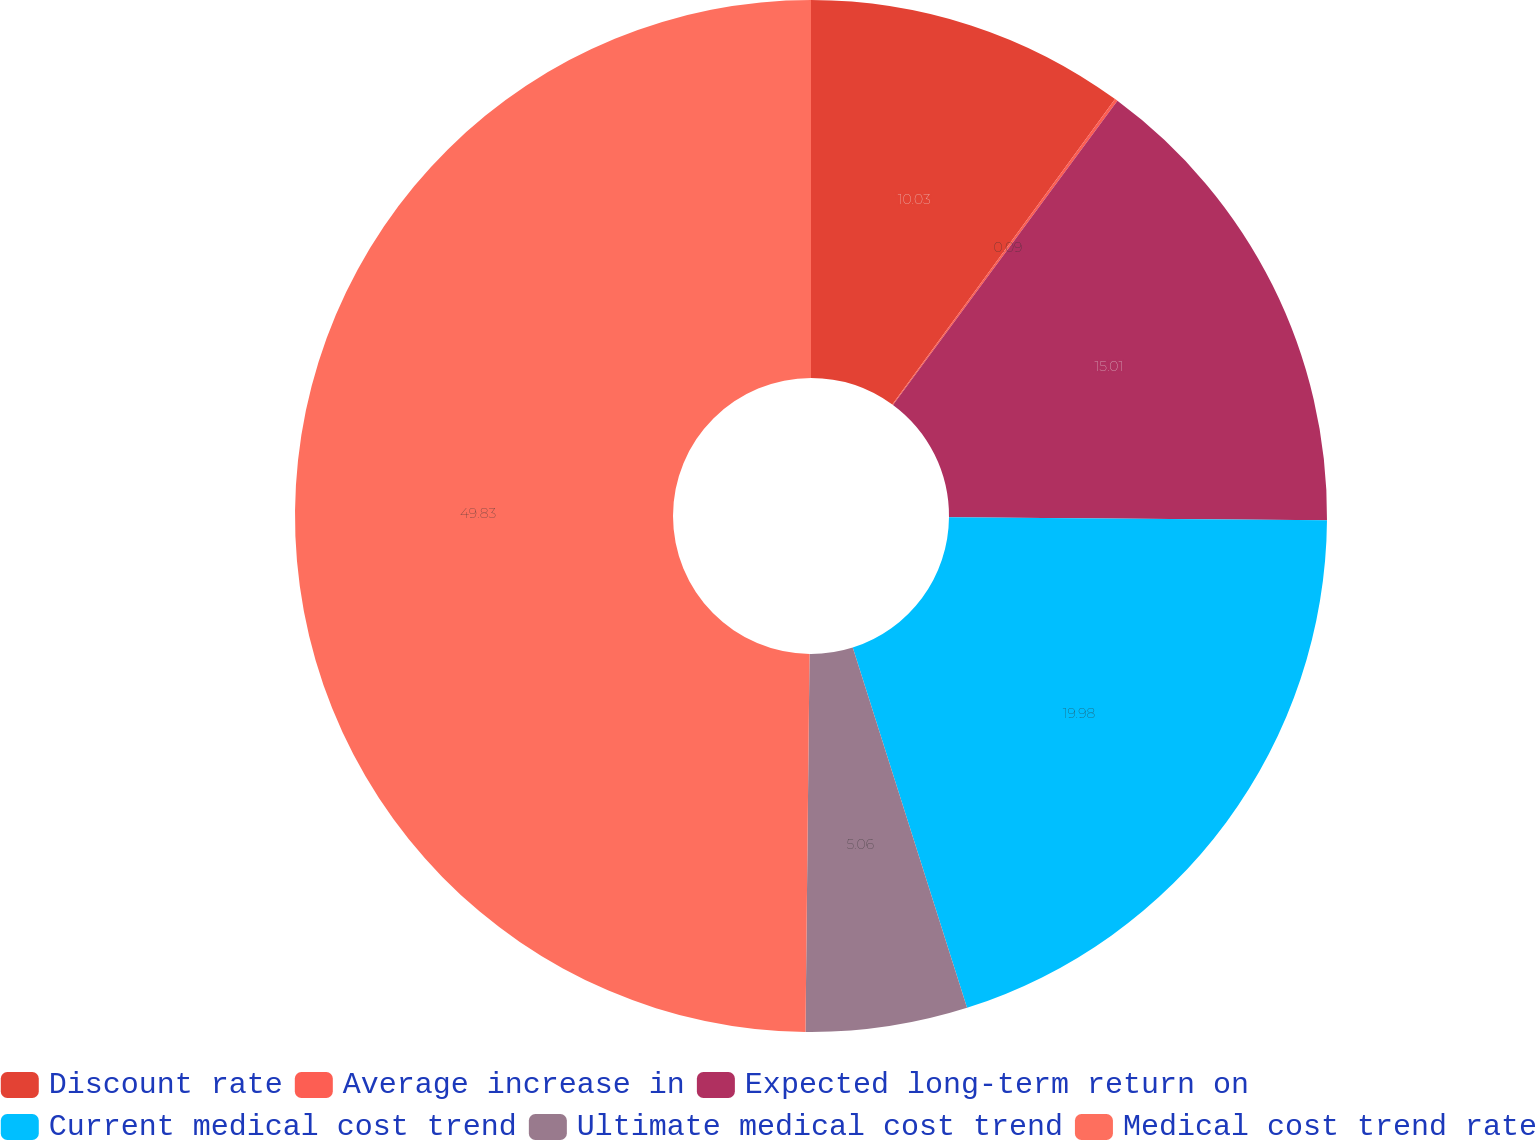Convert chart to OTSL. <chart><loc_0><loc_0><loc_500><loc_500><pie_chart><fcel>Discount rate<fcel>Average increase in<fcel>Expected long-term return on<fcel>Current medical cost trend<fcel>Ultimate medical cost trend<fcel>Medical cost trend rate<nl><fcel>10.03%<fcel>0.09%<fcel>15.01%<fcel>19.98%<fcel>5.06%<fcel>49.83%<nl></chart> 